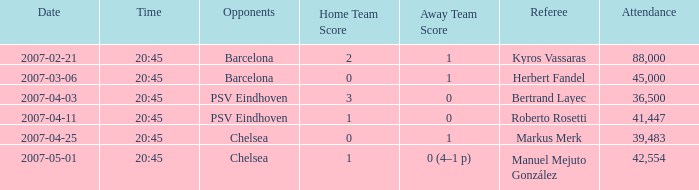What was the result of the match with a 2007-03-06, 20:45 start? 0–1. 